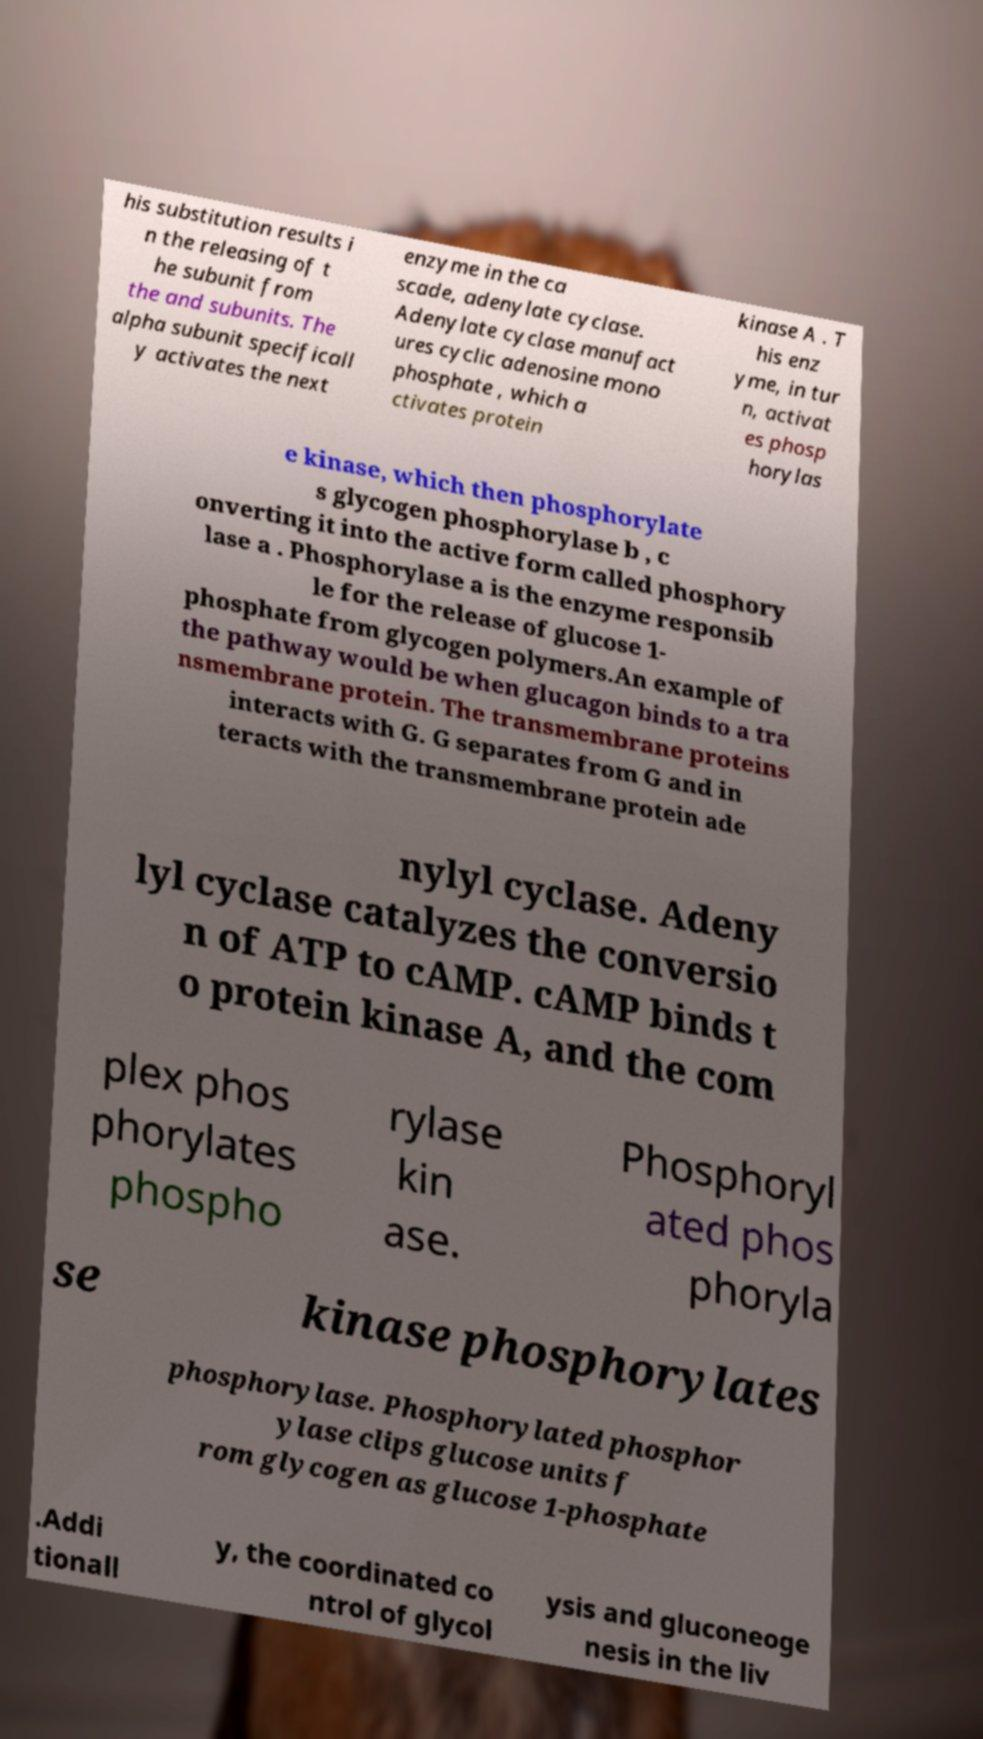I need the written content from this picture converted into text. Can you do that? his substitution results i n the releasing of t he subunit from the and subunits. The alpha subunit specificall y activates the next enzyme in the ca scade, adenylate cyclase. Adenylate cyclase manufact ures cyclic adenosine mono phosphate , which a ctivates protein kinase A . T his enz yme, in tur n, activat es phosp horylas e kinase, which then phosphorylate s glycogen phosphorylase b , c onverting it into the active form called phosphory lase a . Phosphorylase a is the enzyme responsib le for the release of glucose 1- phosphate from glycogen polymers.An example of the pathway would be when glucagon binds to a tra nsmembrane protein. The transmembrane proteins interacts with G. G separates from G and in teracts with the transmembrane protein ade nylyl cyclase. Adeny lyl cyclase catalyzes the conversio n of ATP to cAMP. cAMP binds t o protein kinase A, and the com plex phos phorylates phospho rylase kin ase. Phosphoryl ated phos phoryla se kinase phosphorylates phosphorylase. Phosphorylated phosphor ylase clips glucose units f rom glycogen as glucose 1-phosphate .Addi tionall y, the coordinated co ntrol of glycol ysis and gluconeoge nesis in the liv 